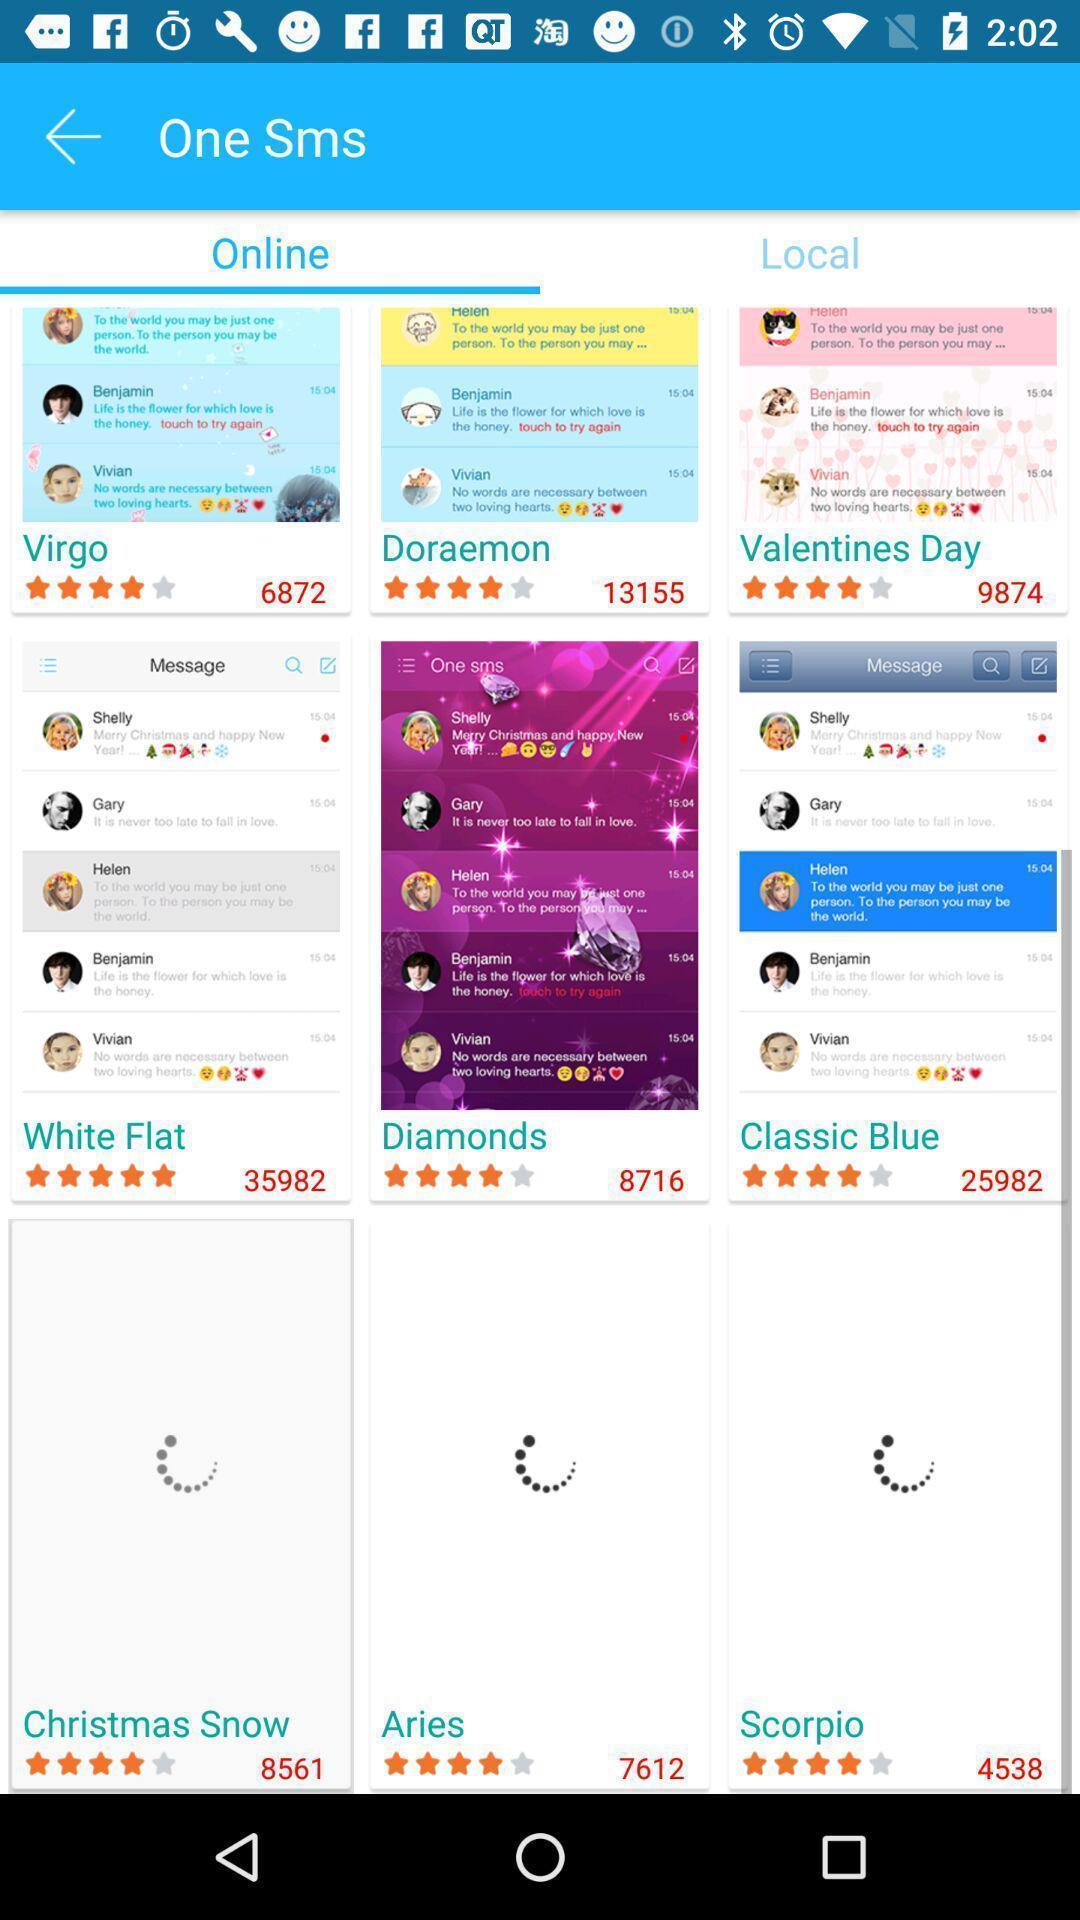Explain the elements present in this screenshot. Screen display various chat themes for a social app. 